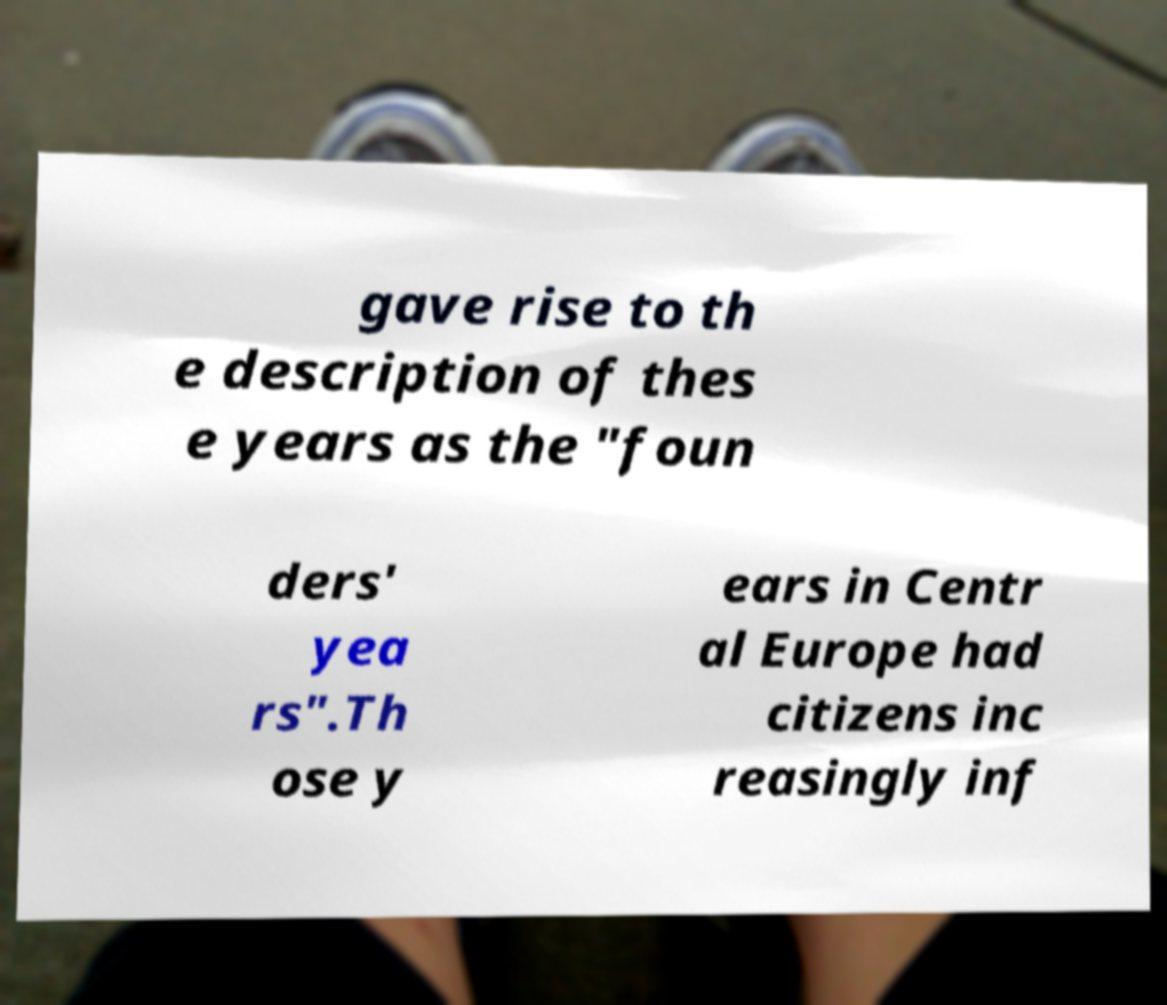For documentation purposes, I need the text within this image transcribed. Could you provide that? gave rise to th e description of thes e years as the "foun ders' yea rs".Th ose y ears in Centr al Europe had citizens inc reasingly inf 